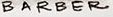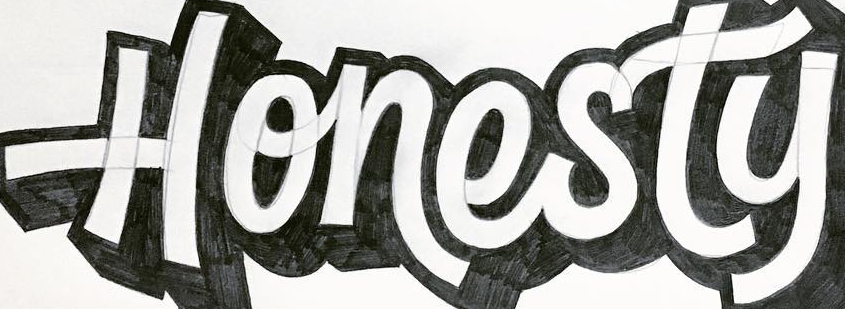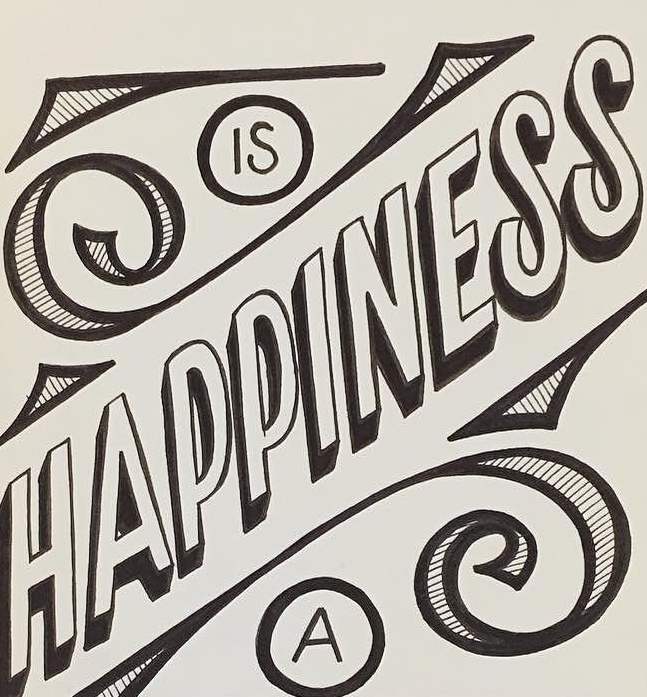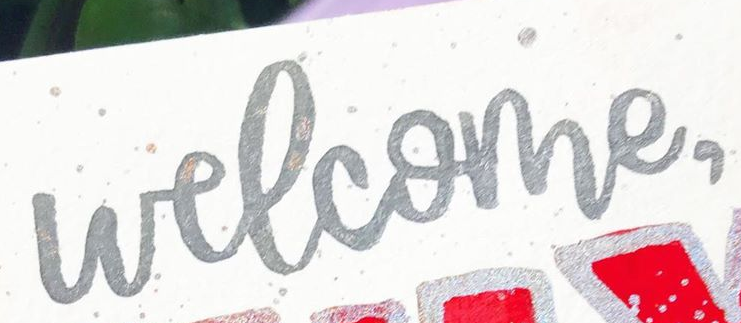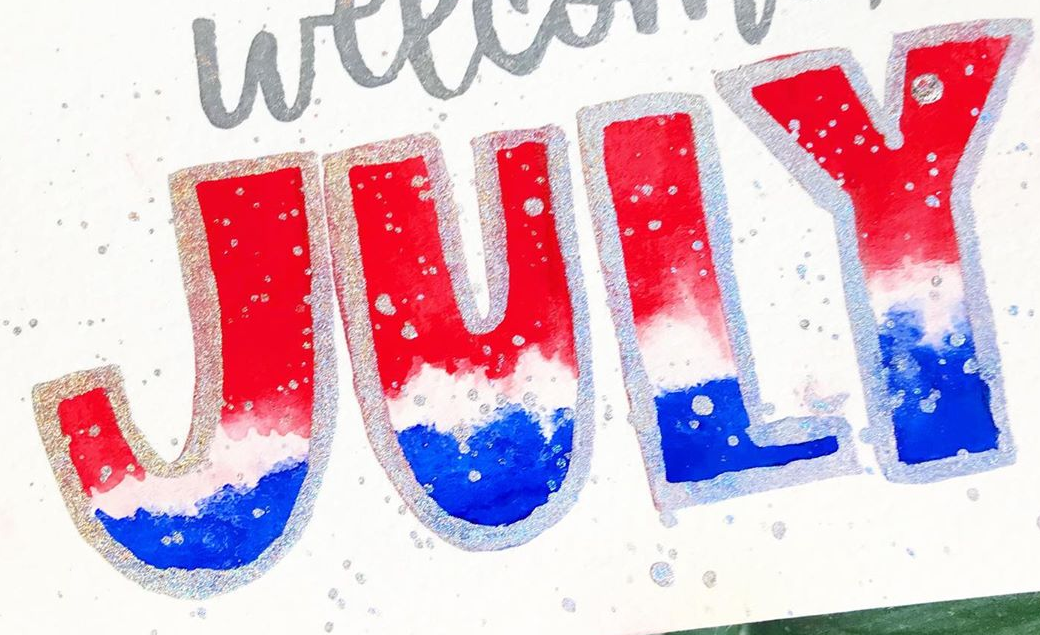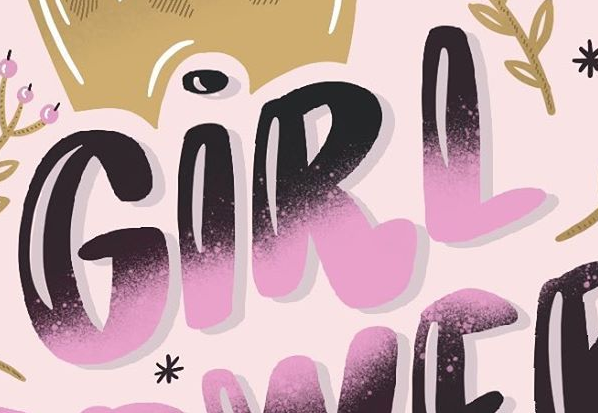What words are shown in these images in order, separated by a semicolon? BARBER; Honesty; HAPPINESS; welcome,; JULY; GIRL 